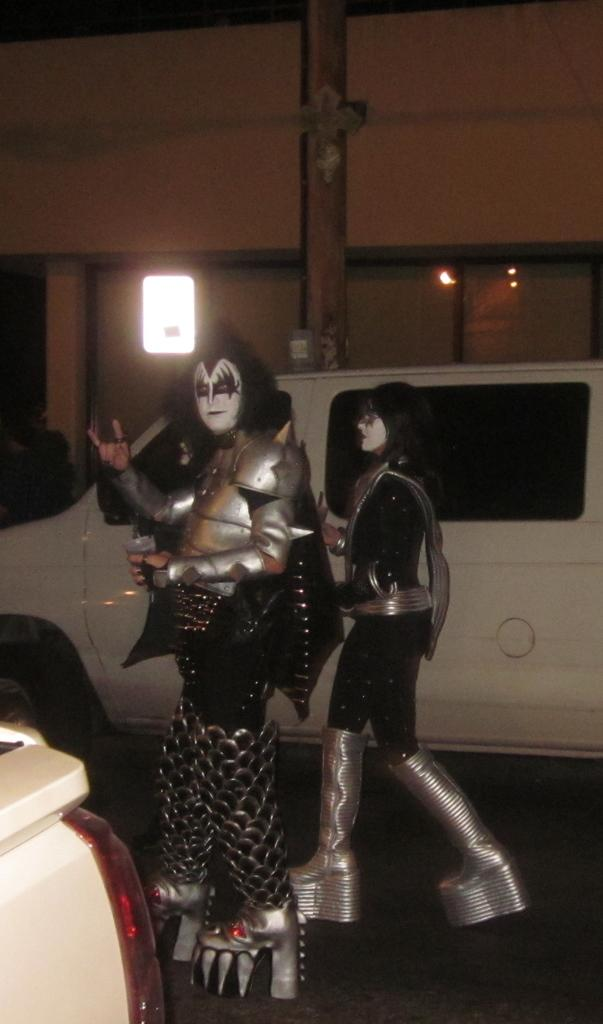What are the two people in the image wearing? The two people in the image are wearing costumes. How are their faces decorated in the image? The people have face painting in the image. What can be seen in the image besides the people? There are two vehicles and a building in the background of the image. What type of jeans is the person wearing in the image? There is no mention of jeans in the image; the people are wearing costumes. Can you recite a verse from the image? There is no text or verse present in the image. 